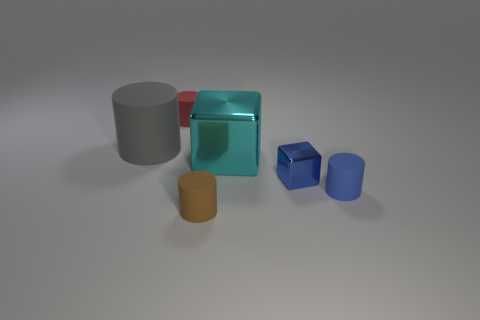What number of things are small brown metallic things or cylinders in front of the big cyan block?
Give a very brief answer. 2. There is a small cylinder that is in front of the small matte object on the right side of the blue block; what is its color?
Make the answer very short. Brown. What number of other objects are the same material as the big gray cylinder?
Keep it short and to the point. 3. How many rubber things are either tiny cylinders or tiny brown things?
Offer a terse response. 3. There is another thing that is the same shape as the cyan object; what is its color?
Offer a terse response. Blue. How many things are blue objects or blue cylinders?
Give a very brief answer. 2. What shape is the other object that is the same material as the cyan thing?
Your response must be concise. Cube. What number of large things are either cyan metal cubes or red rubber things?
Provide a short and direct response. 1. How many other objects are the same color as the big matte object?
Keep it short and to the point. 0. There is a rubber thing left of the matte object that is behind the large cylinder; how many blue metal things are behind it?
Offer a very short reply. 0. 